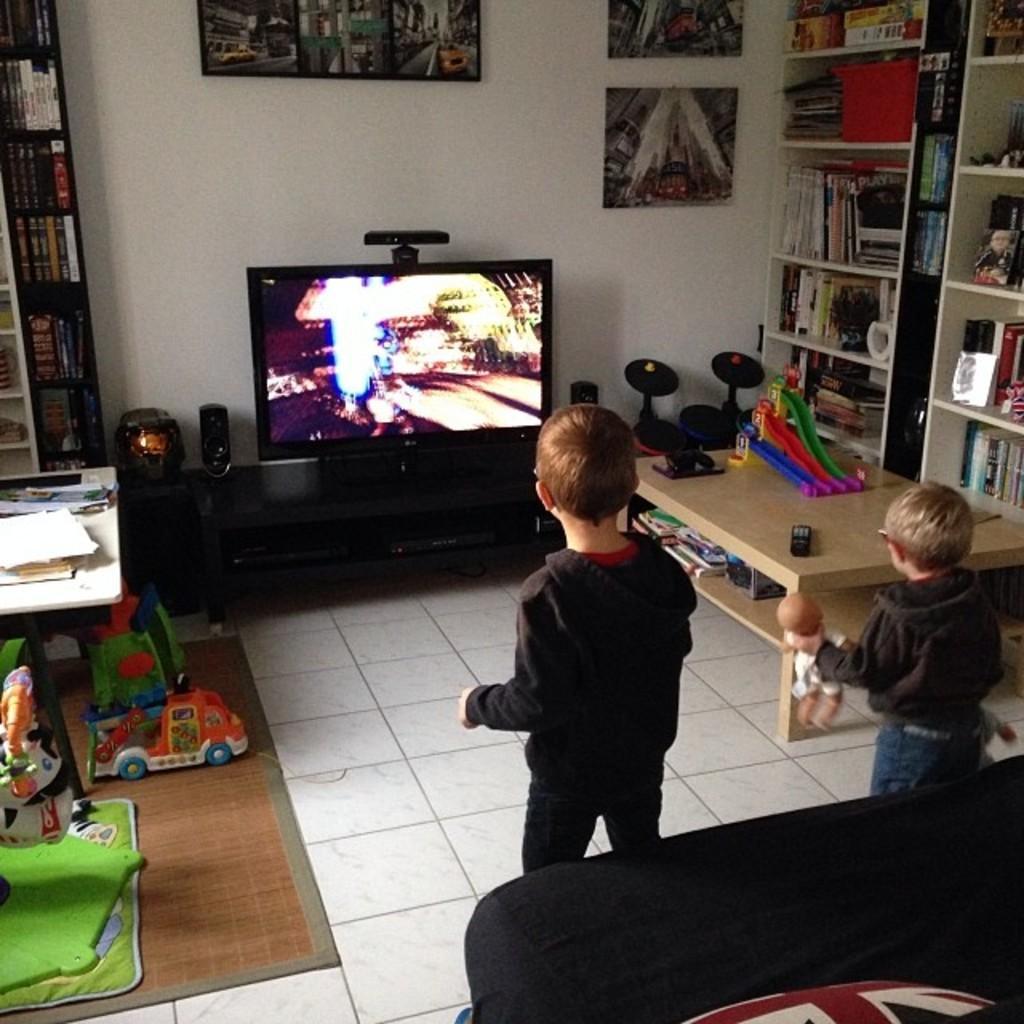Describe this image in one or two sentences. In this image I see 2 children on the floor and one of them is holding a doll. In front there is a T. V. and there are lot of photo frames on the wall. To the right there is a rack full of books and on the left there is a table and few toys on the floor. 